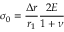Convert formula to latex. <formula><loc_0><loc_0><loc_500><loc_500>\sigma _ { 0 } = \frac { \Delta r } { r _ { 1 } } \frac { 2 E } { 1 + \nu }</formula> 